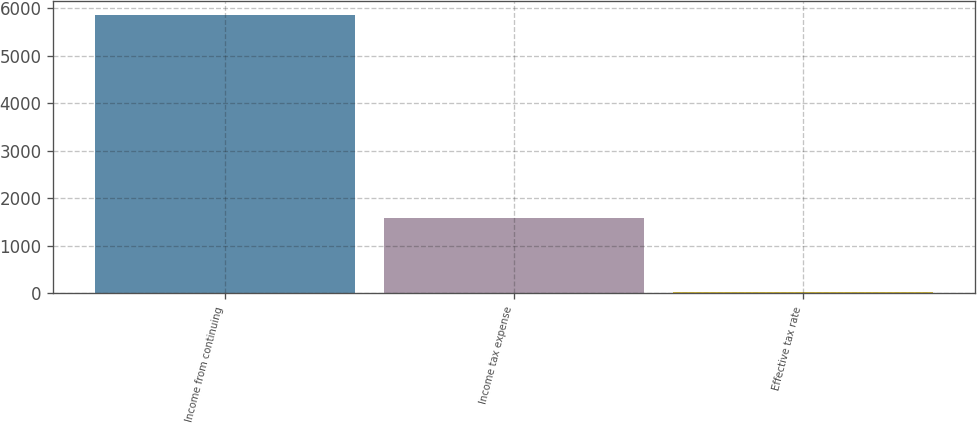Convert chart. <chart><loc_0><loc_0><loc_500><loc_500><bar_chart><fcel>Income from continuing<fcel>Income tax expense<fcel>Effective tax rate<nl><fcel>5856<fcel>1596<fcel>27.3<nl></chart> 